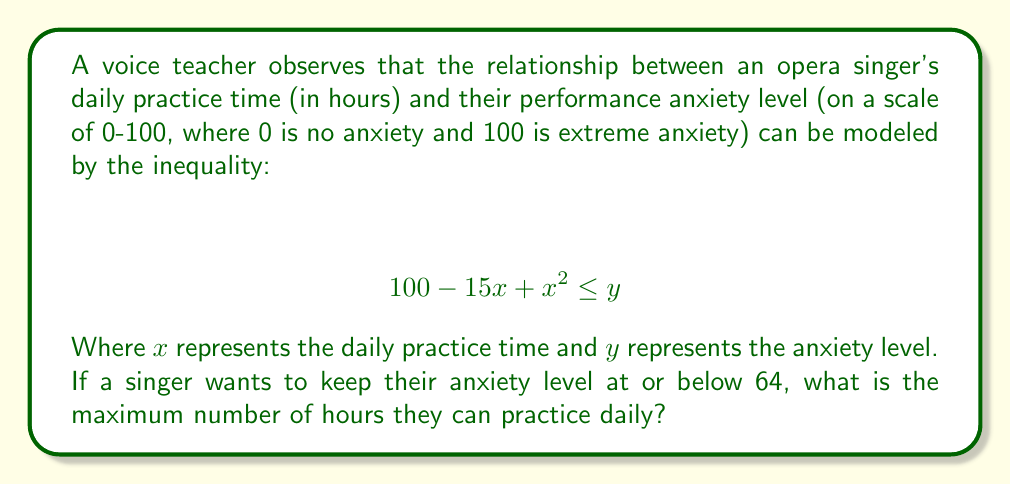Provide a solution to this math problem. To solve this problem, we need to follow these steps:

1) First, we replace the inequality sign with an equality sign and $y$ with 64, as we're looking for the maximum practice time that keeps anxiety at or below 64:

   $$ 100 - 15x + x^2 = 64 $$

2) Rearrange the equation:

   $$ x^2 - 15x + 36 = 0 $$

3) This is a quadratic equation in the form $ax^2 + bx + c = 0$, where $a=1$, $b=-15$, and $c=36$.

4) We can solve this using the quadratic formula: $x = \frac{-b \pm \sqrt{b^2 - 4ac}}{2a}$

5) Substituting our values:

   $$ x = \frac{15 \pm \sqrt{(-15)^2 - 4(1)(36)}}{2(1)} $$

6) Simplify:

   $$ x = \frac{15 \pm \sqrt{225 - 144}}{2} = \frac{15 \pm \sqrt{81}}{2} = \frac{15 \pm 9}{2} $$

7) This gives us two solutions:

   $$ x = \frac{15 + 9}{2} = 12 \quad \text{or} \quad x = \frac{15 - 9}{2} = 3 $$

8) Since we're looking for the maximum number of hours, we choose the larger value, 12.

Therefore, the singer can practice up to 12 hours daily while keeping their anxiety level at or below 64.
Answer: 12 hours 